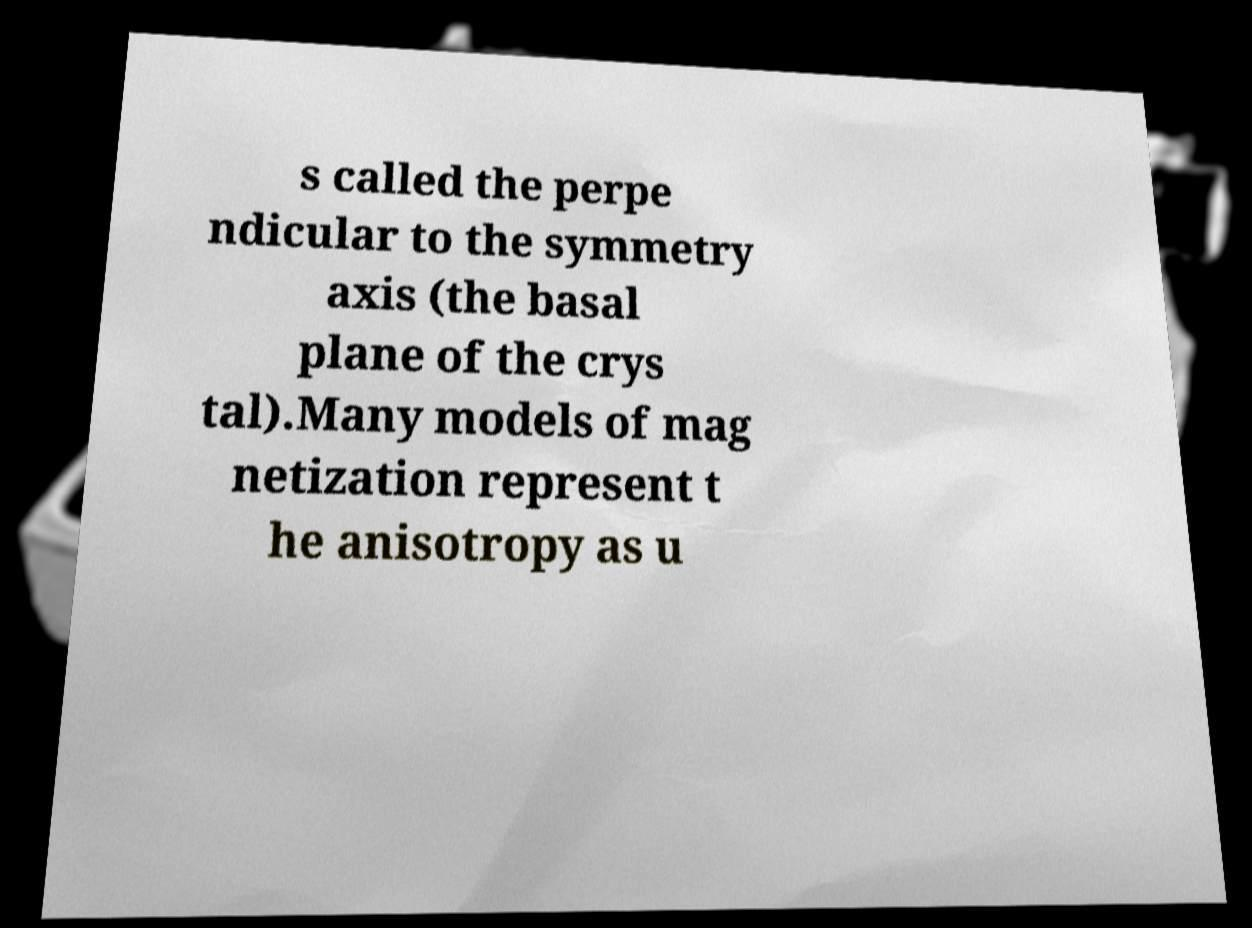I need the written content from this picture converted into text. Can you do that? s called the perpe ndicular to the symmetry axis (the basal plane of the crys tal).Many models of mag netization represent t he anisotropy as u 